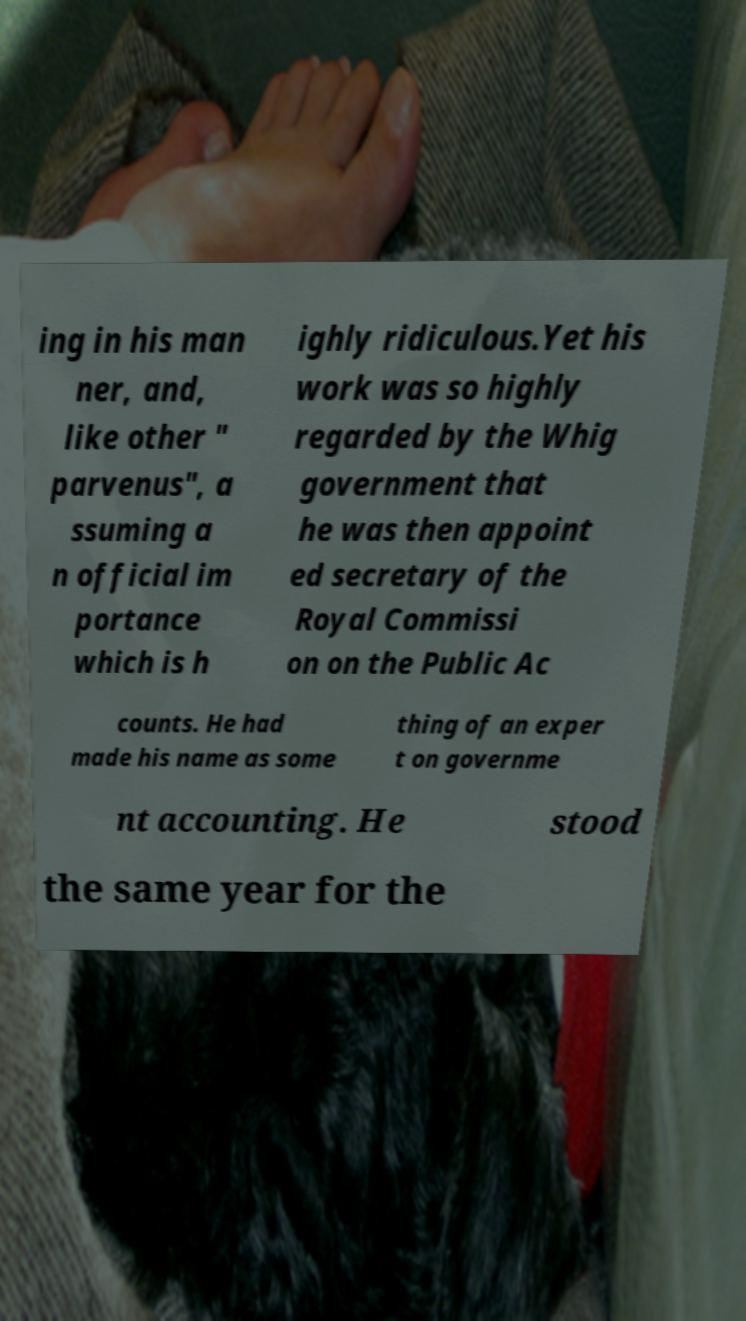There's text embedded in this image that I need extracted. Can you transcribe it verbatim? ing in his man ner, and, like other " parvenus", a ssuming a n official im portance which is h ighly ridiculous.Yet his work was so highly regarded by the Whig government that he was then appoint ed secretary of the Royal Commissi on on the Public Ac counts. He had made his name as some thing of an exper t on governme nt accounting. He stood the same year for the 